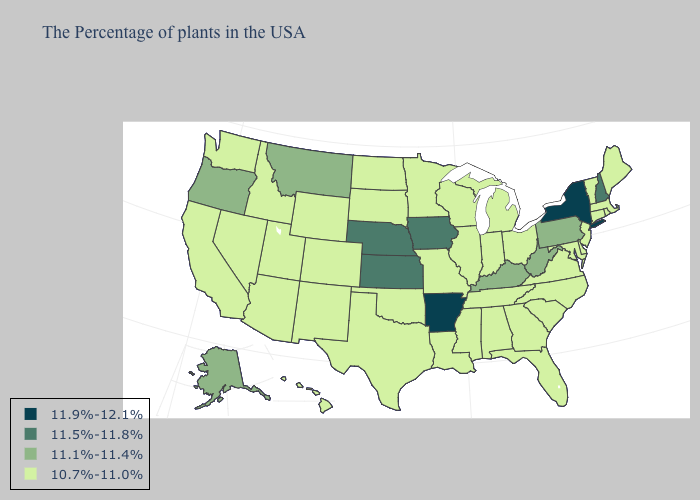Does Arkansas have the highest value in the South?
Short answer required. Yes. Name the states that have a value in the range 11.5%-11.8%?
Give a very brief answer. New Hampshire, Iowa, Kansas, Nebraska. Does Missouri have the lowest value in the USA?
Be succinct. Yes. Does Utah have the highest value in the West?
Be succinct. No. Name the states that have a value in the range 11.1%-11.4%?
Be succinct. Pennsylvania, West Virginia, Kentucky, Montana, Oregon, Alaska. What is the value of New Hampshire?
Be succinct. 11.5%-11.8%. Name the states that have a value in the range 11.9%-12.1%?
Answer briefly. New York, Arkansas. What is the value of Nevada?
Quick response, please. 10.7%-11.0%. What is the lowest value in the USA?
Short answer required. 10.7%-11.0%. Name the states that have a value in the range 11.5%-11.8%?
Quick response, please. New Hampshire, Iowa, Kansas, Nebraska. Does Arkansas have a higher value than New York?
Write a very short answer. No. What is the lowest value in states that border Missouri?
Keep it brief. 10.7%-11.0%. Among the states that border North Carolina , which have the highest value?
Give a very brief answer. Virginia, South Carolina, Georgia, Tennessee. What is the lowest value in the USA?
Short answer required. 10.7%-11.0%. Does Washington have the highest value in the USA?
Keep it brief. No. 